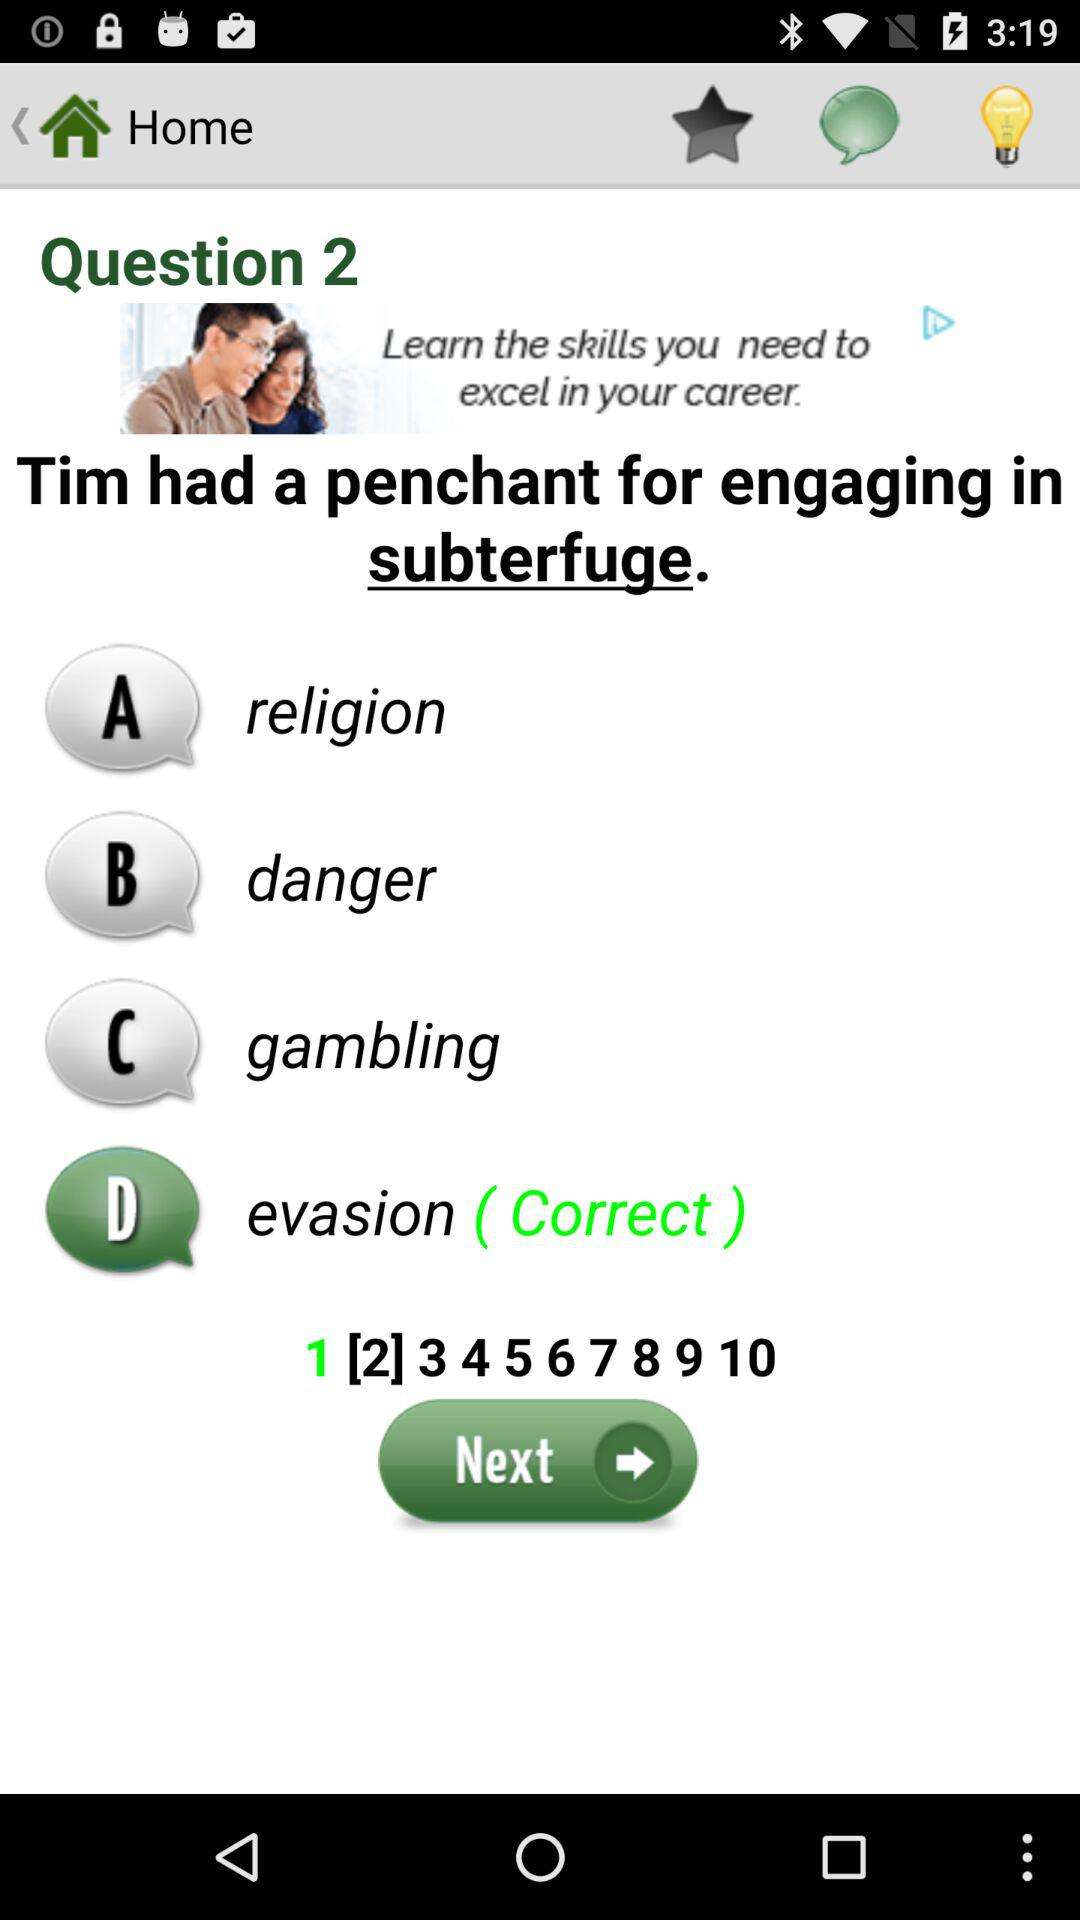What is the correct option? The correct option is "D". 